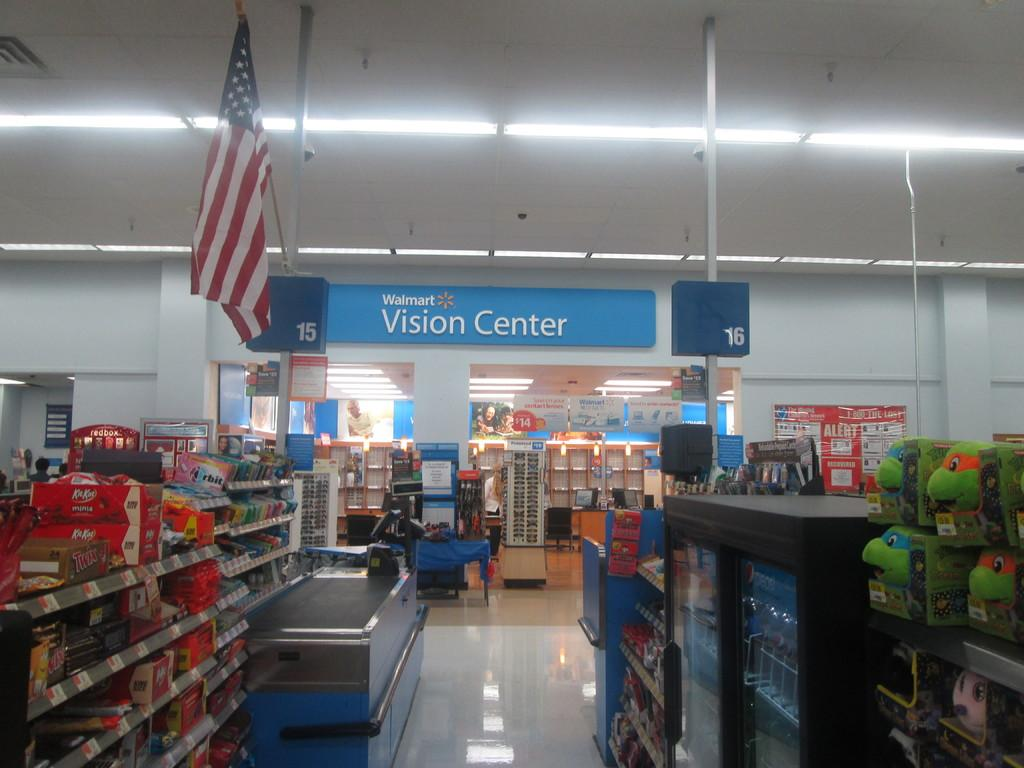<image>
Write a terse but informative summary of the picture. Camera points to the vision center at a walmart 